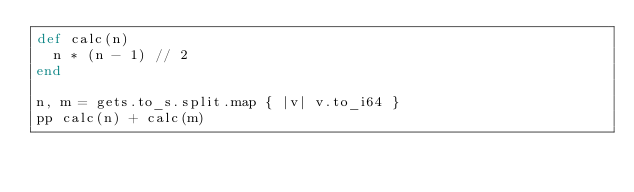Convert code to text. <code><loc_0><loc_0><loc_500><loc_500><_Crystal_>def calc(n)
  n * (n - 1) // 2
end

n, m = gets.to_s.split.map { |v| v.to_i64 }
pp calc(n) + calc(m)
</code> 